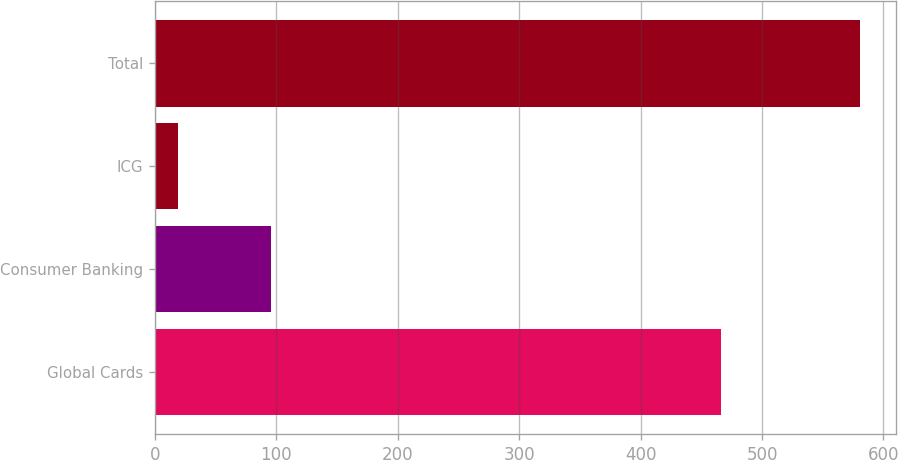Convert chart to OTSL. <chart><loc_0><loc_0><loc_500><loc_500><bar_chart><fcel>Global Cards<fcel>Consumer Banking<fcel>ICG<fcel>Total<nl><fcel>466<fcel>96<fcel>19<fcel>581<nl></chart> 